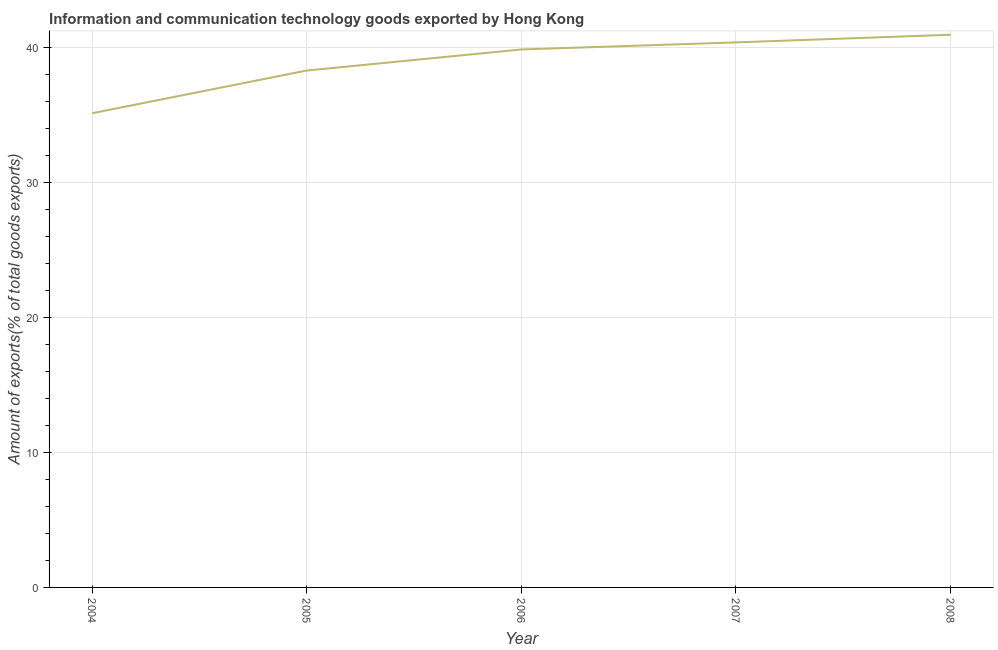What is the amount of ict goods exports in 2008?
Provide a short and direct response. 40.95. Across all years, what is the maximum amount of ict goods exports?
Make the answer very short. 40.95. Across all years, what is the minimum amount of ict goods exports?
Ensure brevity in your answer.  35.13. In which year was the amount of ict goods exports minimum?
Keep it short and to the point. 2004. What is the sum of the amount of ict goods exports?
Your response must be concise. 194.61. What is the difference between the amount of ict goods exports in 2004 and 2006?
Your response must be concise. -4.73. What is the average amount of ict goods exports per year?
Provide a short and direct response. 38.92. What is the median amount of ict goods exports?
Your response must be concise. 39.86. In how many years, is the amount of ict goods exports greater than 22 %?
Offer a terse response. 5. Do a majority of the years between 2006 and 2004 (inclusive) have amount of ict goods exports greater than 8 %?
Your answer should be very brief. No. What is the ratio of the amount of ict goods exports in 2004 to that in 2007?
Offer a terse response. 0.87. What is the difference between the highest and the second highest amount of ict goods exports?
Keep it short and to the point. 0.57. What is the difference between the highest and the lowest amount of ict goods exports?
Give a very brief answer. 5.82. In how many years, is the amount of ict goods exports greater than the average amount of ict goods exports taken over all years?
Offer a very short reply. 3. How many lines are there?
Keep it short and to the point. 1. How many years are there in the graph?
Offer a terse response. 5. Are the values on the major ticks of Y-axis written in scientific E-notation?
Keep it short and to the point. No. Does the graph contain any zero values?
Give a very brief answer. No. Does the graph contain grids?
Your response must be concise. Yes. What is the title of the graph?
Provide a succinct answer. Information and communication technology goods exported by Hong Kong. What is the label or title of the X-axis?
Provide a succinct answer. Year. What is the label or title of the Y-axis?
Provide a succinct answer. Amount of exports(% of total goods exports). What is the Amount of exports(% of total goods exports) of 2004?
Ensure brevity in your answer.  35.13. What is the Amount of exports(% of total goods exports) of 2005?
Your answer should be compact. 38.29. What is the Amount of exports(% of total goods exports) in 2006?
Make the answer very short. 39.86. What is the Amount of exports(% of total goods exports) in 2007?
Your response must be concise. 40.38. What is the Amount of exports(% of total goods exports) in 2008?
Your response must be concise. 40.95. What is the difference between the Amount of exports(% of total goods exports) in 2004 and 2005?
Offer a terse response. -3.16. What is the difference between the Amount of exports(% of total goods exports) in 2004 and 2006?
Your answer should be very brief. -4.73. What is the difference between the Amount of exports(% of total goods exports) in 2004 and 2007?
Keep it short and to the point. -5.25. What is the difference between the Amount of exports(% of total goods exports) in 2004 and 2008?
Offer a very short reply. -5.82. What is the difference between the Amount of exports(% of total goods exports) in 2005 and 2006?
Your answer should be very brief. -1.56. What is the difference between the Amount of exports(% of total goods exports) in 2005 and 2007?
Give a very brief answer. -2.09. What is the difference between the Amount of exports(% of total goods exports) in 2005 and 2008?
Give a very brief answer. -2.65. What is the difference between the Amount of exports(% of total goods exports) in 2006 and 2007?
Provide a succinct answer. -0.52. What is the difference between the Amount of exports(% of total goods exports) in 2006 and 2008?
Ensure brevity in your answer.  -1.09. What is the difference between the Amount of exports(% of total goods exports) in 2007 and 2008?
Make the answer very short. -0.57. What is the ratio of the Amount of exports(% of total goods exports) in 2004 to that in 2005?
Offer a very short reply. 0.92. What is the ratio of the Amount of exports(% of total goods exports) in 2004 to that in 2006?
Provide a succinct answer. 0.88. What is the ratio of the Amount of exports(% of total goods exports) in 2004 to that in 2007?
Ensure brevity in your answer.  0.87. What is the ratio of the Amount of exports(% of total goods exports) in 2004 to that in 2008?
Give a very brief answer. 0.86. What is the ratio of the Amount of exports(% of total goods exports) in 2005 to that in 2006?
Your answer should be very brief. 0.96. What is the ratio of the Amount of exports(% of total goods exports) in 2005 to that in 2007?
Give a very brief answer. 0.95. What is the ratio of the Amount of exports(% of total goods exports) in 2005 to that in 2008?
Offer a very short reply. 0.94. What is the ratio of the Amount of exports(% of total goods exports) in 2006 to that in 2008?
Provide a short and direct response. 0.97. 